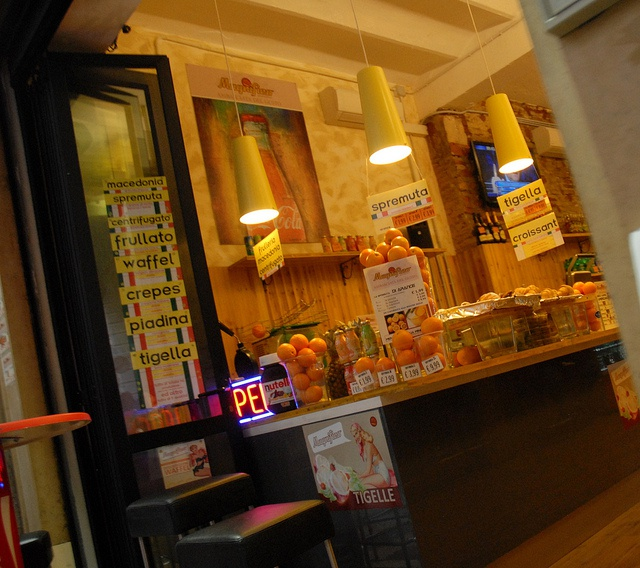Describe the objects in this image and their specific colors. I can see refrigerator in black, olive, and maroon tones, chair in black, maroon, and brown tones, orange in black, brown, maroon, and red tones, dining table in black, maroon, and red tones, and tv in black, gray, navy, and maroon tones in this image. 